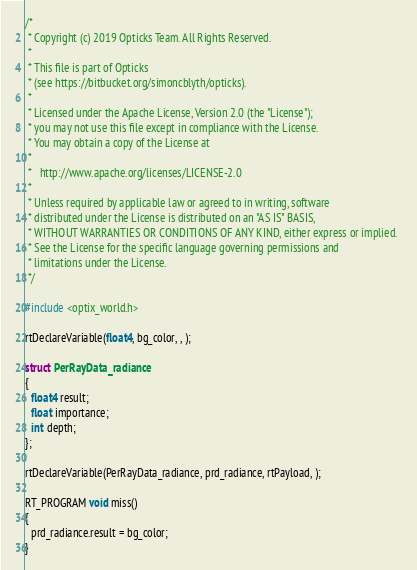Convert code to text. <code><loc_0><loc_0><loc_500><loc_500><_Cuda_>/*
 * Copyright (c) 2019 Opticks Team. All Rights Reserved.
 *
 * This file is part of Opticks
 * (see https://bitbucket.org/simoncblyth/opticks).
 *
 * Licensed under the Apache License, Version 2.0 (the "License"); 
 * you may not use this file except in compliance with the License.  
 * You may obtain a copy of the License at
 *
 *   http://www.apache.org/licenses/LICENSE-2.0
 *
 * Unless required by applicable law or agreed to in writing, software 
 * distributed under the License is distributed on an "AS IS" BASIS, 
 * WITHOUT WARRANTIES OR CONDITIONS OF ANY KIND, either express or implied.  
 * See the License for the specific language governing permissions and 
 * limitations under the License.
 */

#include <optix_world.h>

rtDeclareVariable(float4, bg_color, , );

struct PerRayData_radiance
{
  float4 result;
  float importance;
  int depth;
};

rtDeclareVariable(PerRayData_radiance, prd_radiance, rtPayload, );

RT_PROGRAM void miss()
{
  prd_radiance.result = bg_color;
}
</code> 